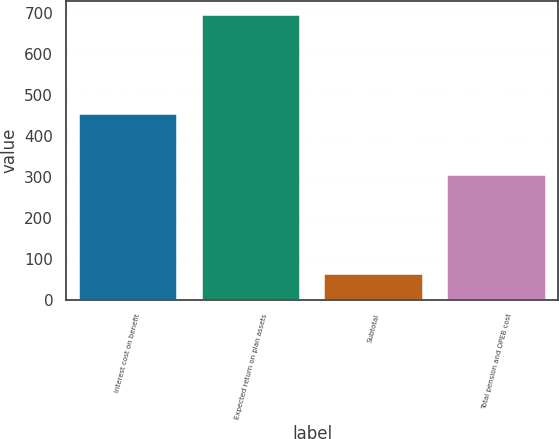<chart> <loc_0><loc_0><loc_500><loc_500><bar_chart><fcel>Interest cost on benefit<fcel>Expected return on plan assets<fcel>Subtotal<fcel>Total pension and OPEB cost<nl><fcel>453<fcel>694<fcel>64<fcel>304<nl></chart> 